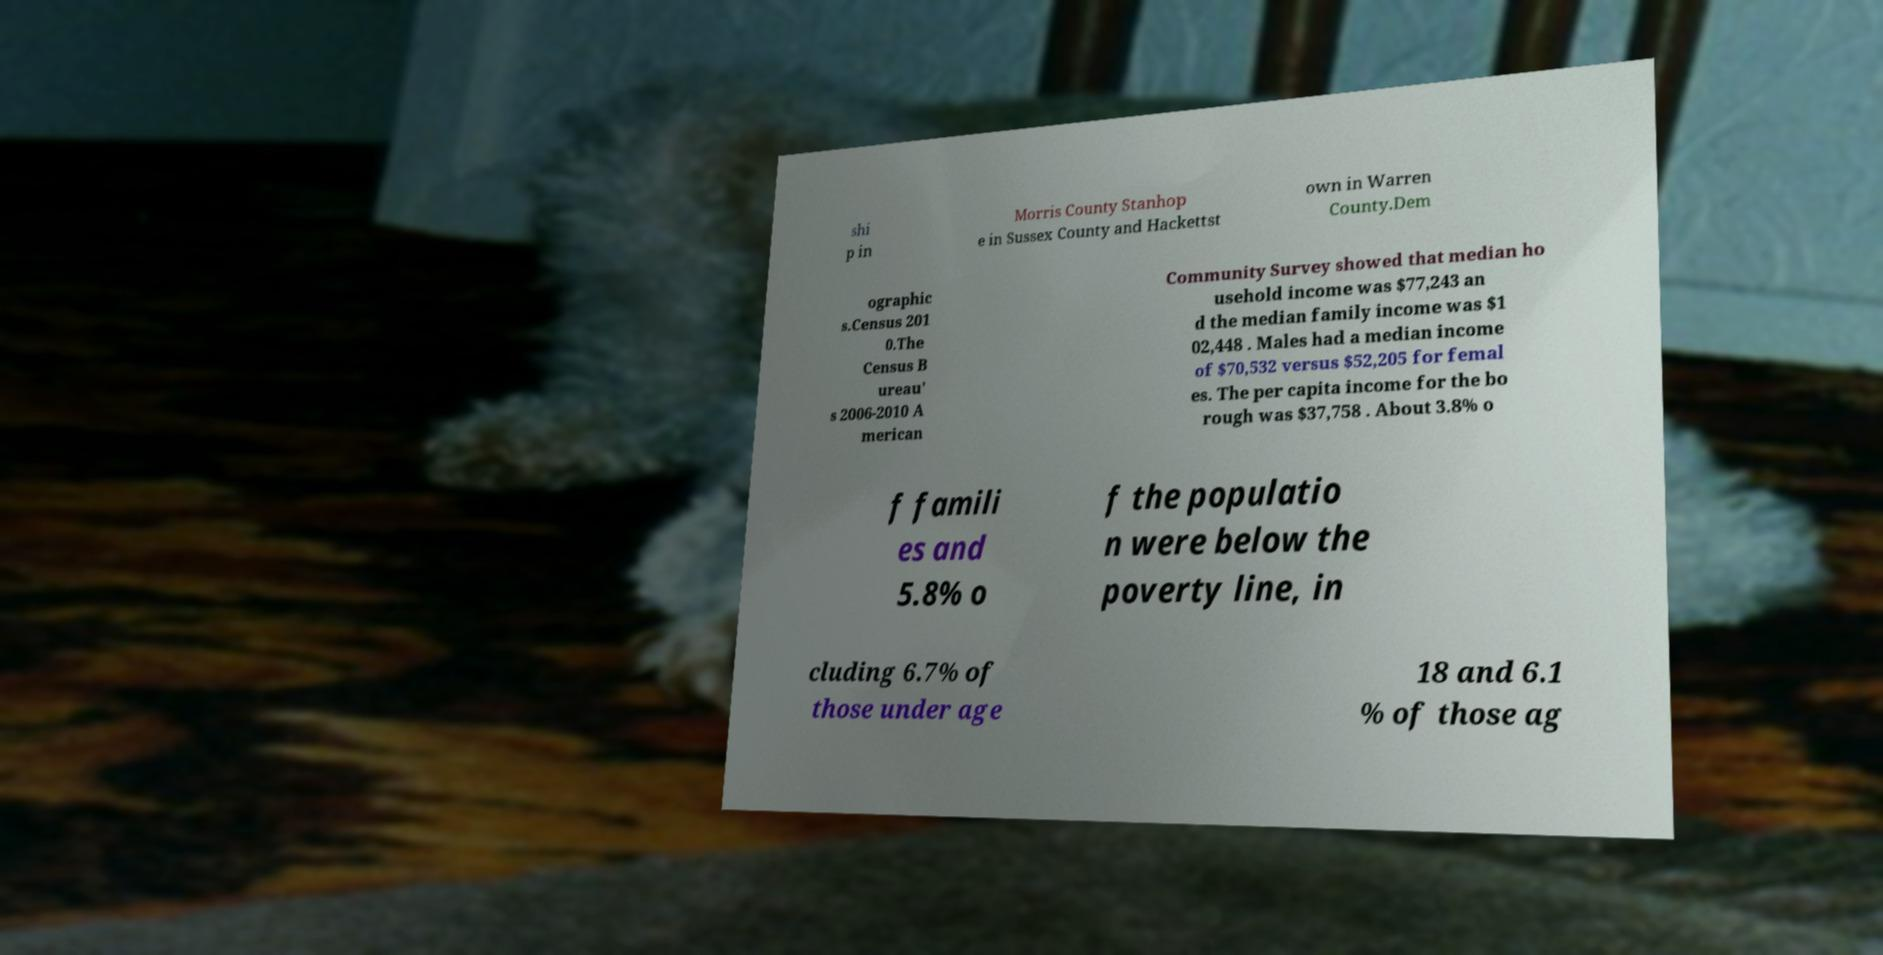I need the written content from this picture converted into text. Can you do that? shi p in Morris County Stanhop e in Sussex County and Hackettst own in Warren County.Dem ographic s.Census 201 0.The Census B ureau' s 2006-2010 A merican Community Survey showed that median ho usehold income was $77,243 an d the median family income was $1 02,448 . Males had a median income of $70,532 versus $52,205 for femal es. The per capita income for the bo rough was $37,758 . About 3.8% o f famili es and 5.8% o f the populatio n were below the poverty line, in cluding 6.7% of those under age 18 and 6.1 % of those ag 